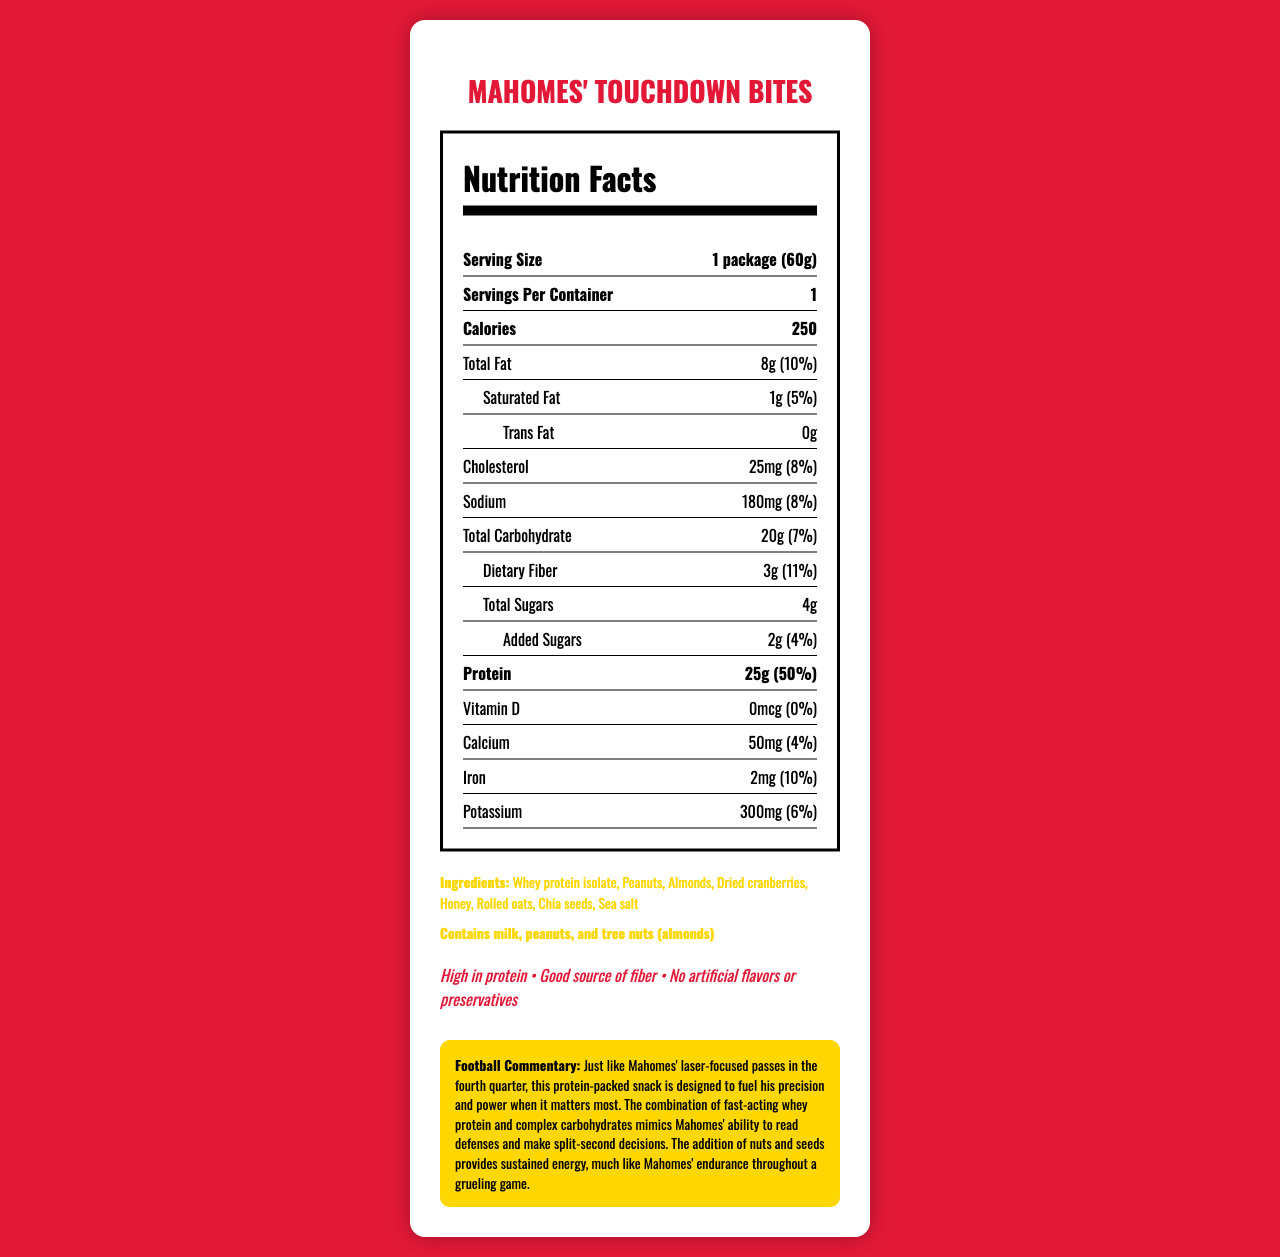what is the serving size of Mahomes' Touchdown Bites? The serving size is listed as "1 package (60g)" on the Nutrition Facts Label.
Answer: 1 package (60g) how many calories are in one package of Mahomes' Touchdown Bites? The document states that one package of Mahomes' Touchdown Bites contains 250 calories.
Answer: 250 what is the total fat content, and its percentage of the daily value? The total fat content is 8g, which is 10% of the daily value, as indicated on the label.
Answer: 8g, 10% how much protein does this snack provide? The protein content listed is 25g per serving.
Answer: 25g what is the amount of dietary fiber in Mahomes' Touchdown Bites? The Nutrition Facts Label specifies that the dietary fiber content is 3g.
Answer: 3g does this product contain any trans fat? The document explicitly states that there are 0g of trans fat in Mahomes' Touchdown Bites.
Answer: No what are the allergens present in Mahomes' Touchdown Bites? A. Gluten B. Dairy C. Peanuts D. Tree nuts The document lists "Contains milk, peanuts, and tree nuts (almonds)" as allergens.
Answer: B, C, D which claim is NOT made about Mahomes' Touchdown Bites? A. High in protein B. Good source of fiber C. Low in sodium D. No artificial flavors or preservatives The claims made are: High in protein, Good source of fiber, No artificial flavors or preservatives.
Answer: C. Low in sodium is there any Vitamin D in this snack? The Vitamin D amount is listed as "0mcg (0%)", indicating there is no Vitamin D in the snack.
Answer: No summarize the main idea of the document. The document details the nutritional content and ingredients of the snack, emphasizing its high protein and fiber content, and links its benefits to Mahomes' athletic performance.
Answer: The document provides the Nutrition Facts Label for "Mahomes' Touchdown Bites," a high-protein snack designed to fuel Patrick Mahomes' fourth-quarter performance. It includes key nutritional information, ingredients, allergens, and claims about the product, along with a football-related commentary on how the snack supports Mahomes' game performance. what is the highest percentage of daily value among the listed nutrients? The protein content at 25g corresponds to 50% of the daily value, which is the highest percentage listed.
Answer: 50% (Protein) can you determine how much honey is used in the snack from the document? The document lists honey as an ingredient but does not specify the quantity used.
Answer: Cannot be determined how much cholesterol does Mahomes' Touchdown Bites contain? The document states that the cholesterol content is 25mg.
Answer: 25mg how much added sugars does this product contain? The added sugars amount is listed as 2g on the Nutrition Facts Label.
Answer: 2g 